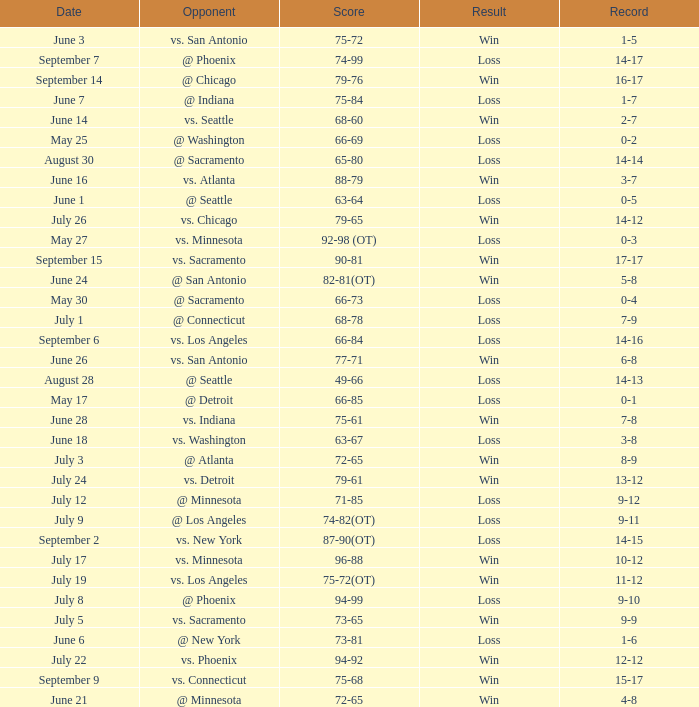What was the Result on July 24? Win. 